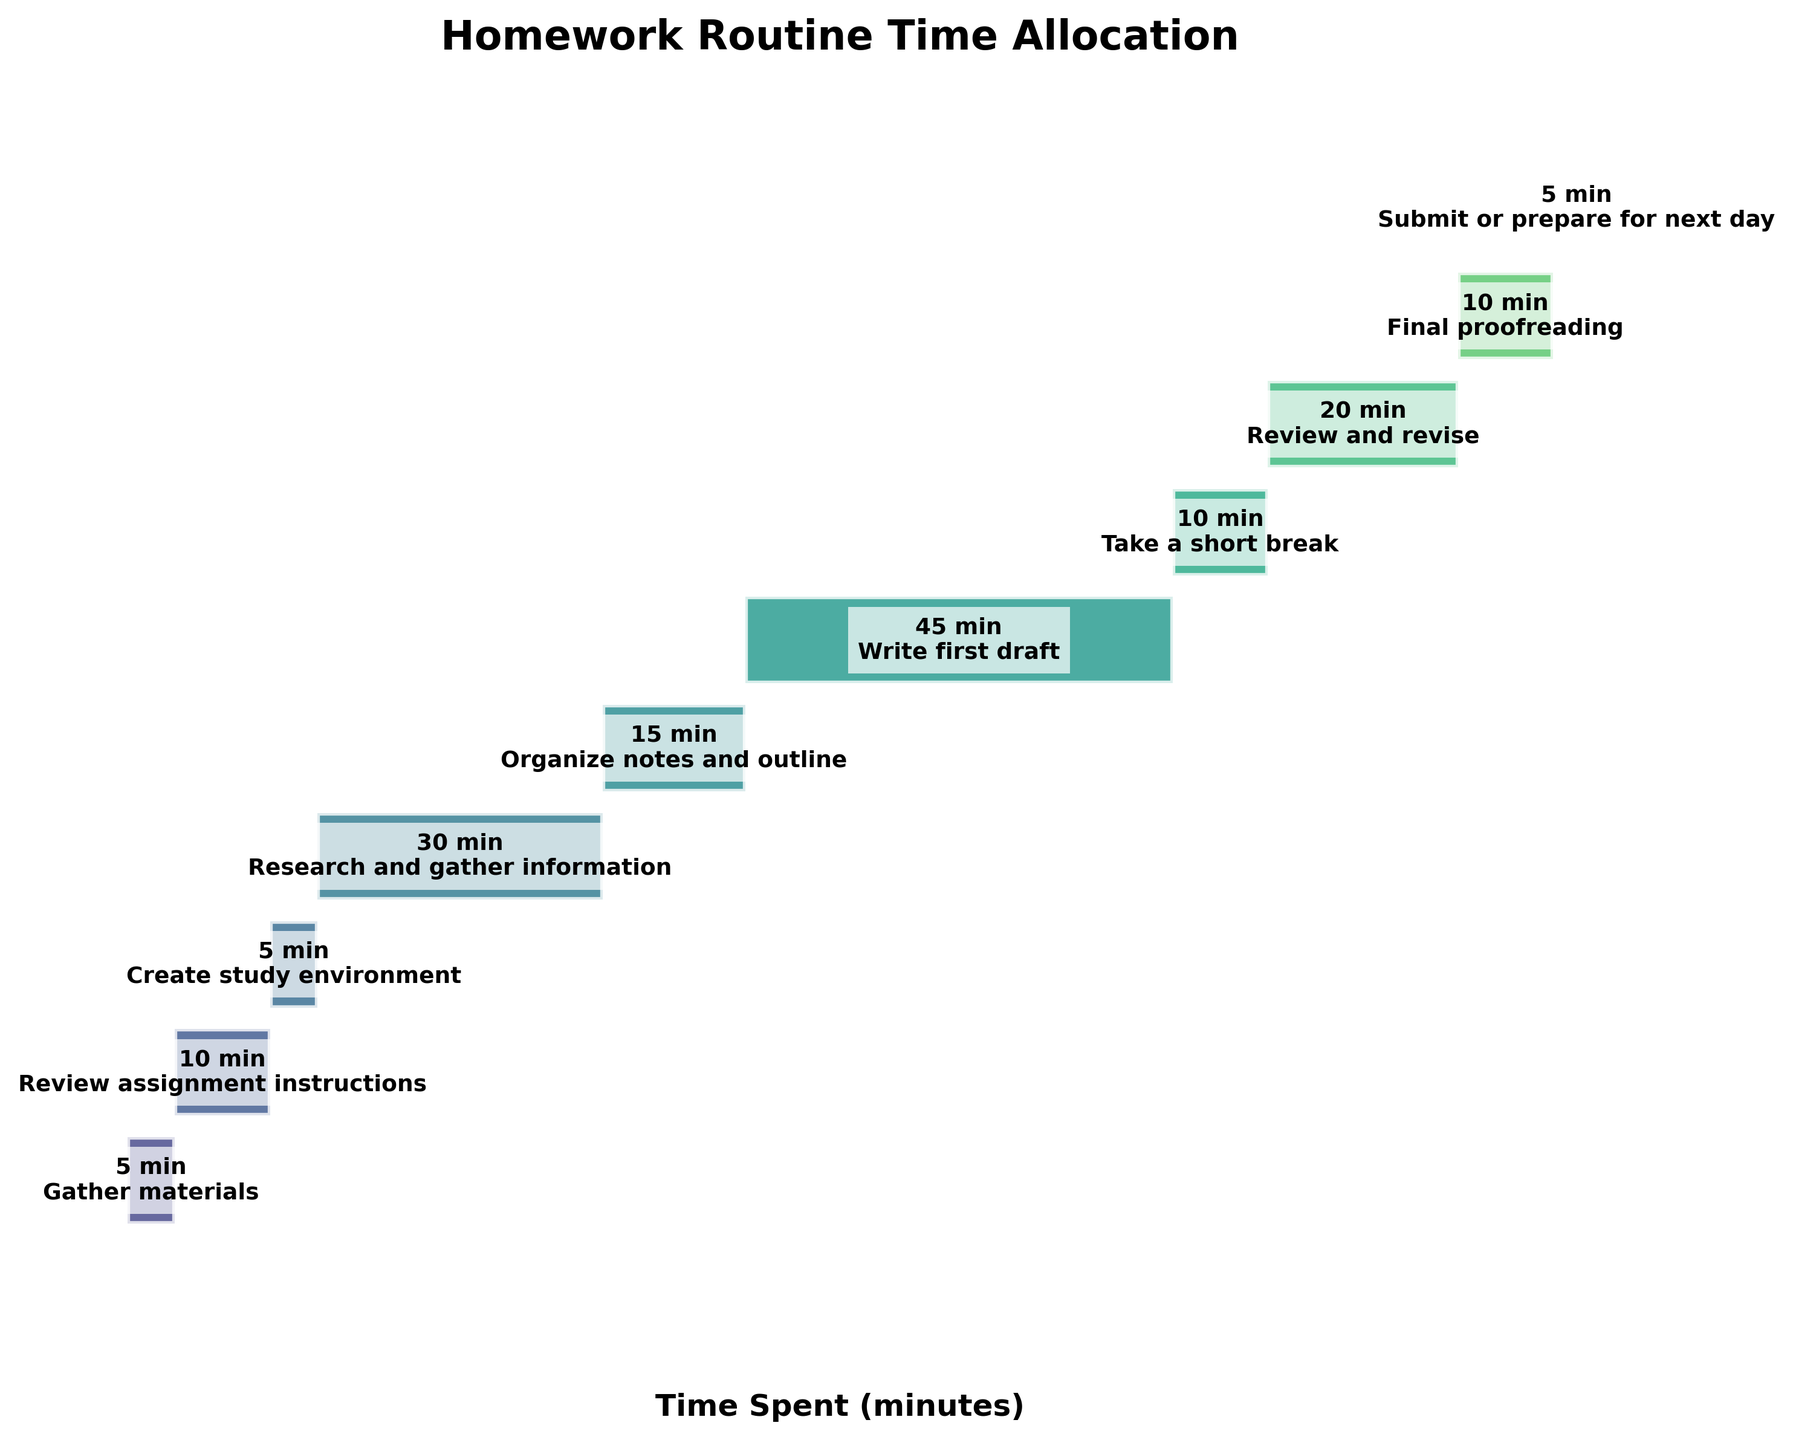Which stage takes the most time? The "Write first draft" stage takes the most time since it has the longest bar.
Answer: Write first draft (45 minutes) What's the total time spent on all stages? Sum the time allocated to each stage: 5 + 10 + 5 + 30 + 15 + 45 + 10 + 20 + 10 + 5 = 155 minutes.
Answer: 155 minutes How many stages are there in the homework routine? The number of stages is equal to the number of bars listed in the chart.
Answer: 10 stages What is the difference in time between "Research and gather information" and "Organize notes and outline"? Subtract the time for "Organize notes and outline" from "Research and gather information": 30 - 15 = 15 minutes.
Answer: 15 minutes Which stages take exactly 10 minutes? Identify the bars labeled with "10 min." They are "Review assignment instructions," "Take a short break," and "Final proofreading."
Answer: Review assignment instructions, Take a short break, Final proofreading How much more time is spent on "Review and revise" compared to "Submit or prepare for next day"? Subtract the time for "Submit or prepare for next day" from "Review and revise": 20 - 5 = 15 minutes.
Answer: 15 minutes What is the average time spent per stage? Divide the total time by the number of stages: 155 minutes / 10 stages = 15.5 minutes per stage.
Answer: 15.5 minutes What percentage of the entire routine is "Write first draft" stage? Calculate the percentage: (45 minutes / 155 minutes) * 100% ≈ 29.03%.
Answer: Approximately 29% Which stage follows "Create study environment"? The stage listed directly below "Create study environment" is "Research and gather information."
Answer: Research and gather information Is "Review assignment instructions" longer or shorter than "Organize notes and outline"? Compare the times: "Review assignment instructions" (10 minutes) is shorter than "Organize notes and outline" (15 minutes).
Answer: Shorter 